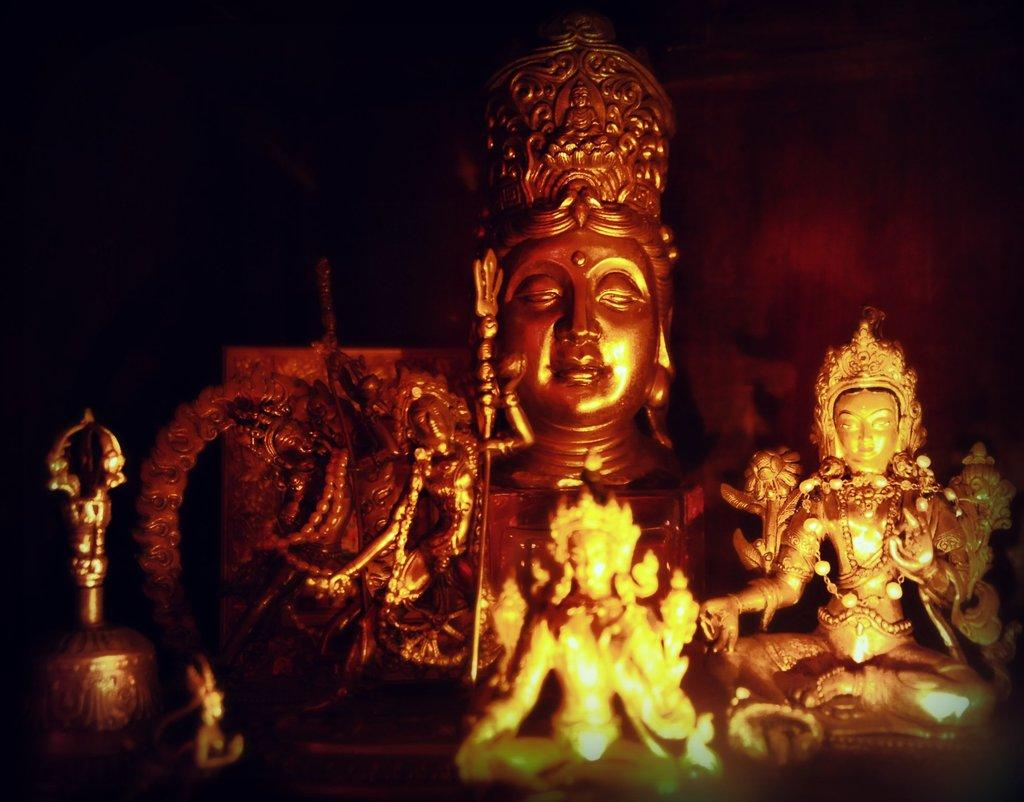What is located in the center of the image? There are sculptures and ornaments in the center of the image. Can you describe the background of the image? The background of the image is dark. What type of stomach pain is the person experiencing in the image? There is no person or indication of stomach pain present in the image. What type of club can be seen in the image? There is no club present in the image. What is being copied in the image? There is no indication of copying or duplication in the image. 